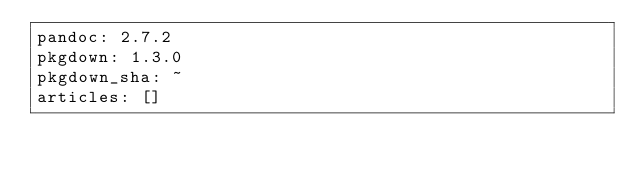<code> <loc_0><loc_0><loc_500><loc_500><_YAML_>pandoc: 2.7.2
pkgdown: 1.3.0
pkgdown_sha: ~
articles: []

</code> 